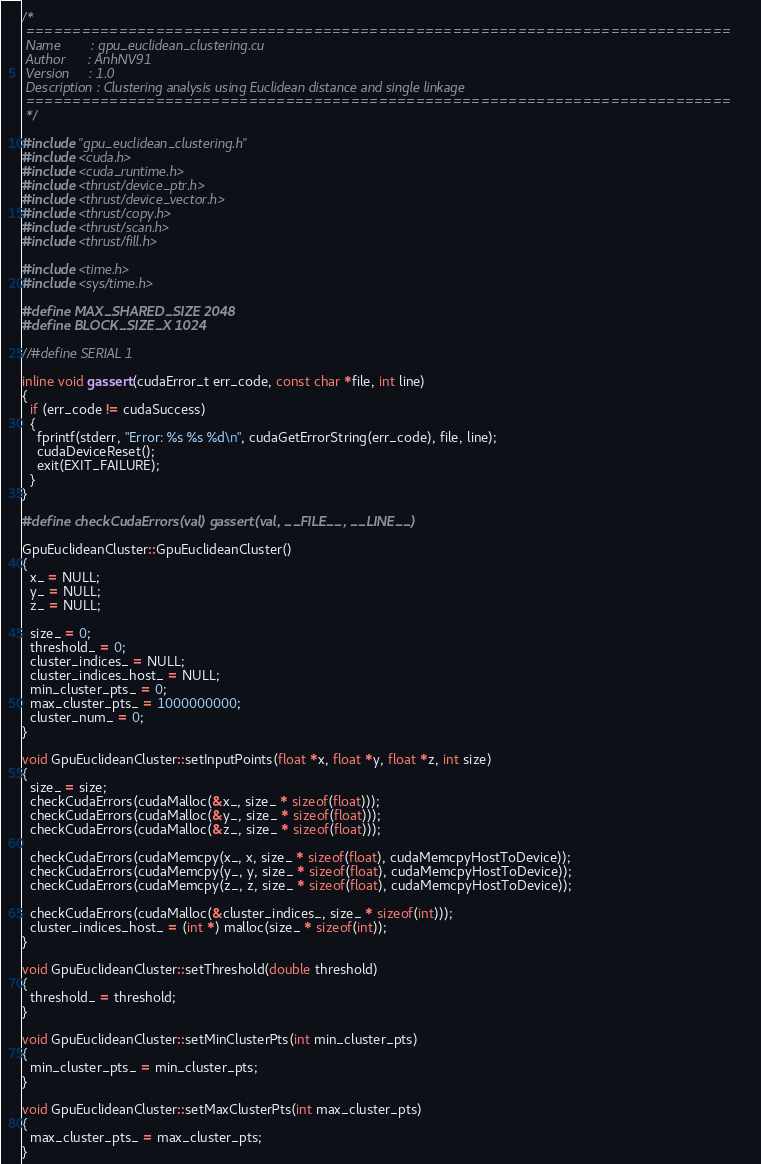Convert code to text. <code><loc_0><loc_0><loc_500><loc_500><_Cuda_>/*
 ============================================================================
 Name        : gpu_euclidean_clustering.cu
 Author      : AnhNV91
 Version     : 1.0
 Description : Clustering analysis using Euclidean distance and single linkage
 ============================================================================
 */

#include "gpu_euclidean_clustering.h"
#include <cuda.h>
#include <cuda_runtime.h>
#include <thrust/device_ptr.h>
#include <thrust/device_vector.h>
#include <thrust/copy.h>
#include <thrust/scan.h>
#include <thrust/fill.h>

#include <time.h>
#include <sys/time.h>

#define MAX_SHARED_SIZE 2048
#define BLOCK_SIZE_X 1024

//#define SERIAL 1

inline void gassert(cudaError_t err_code, const char *file, int line)
{
  if (err_code != cudaSuccess)
  {
    fprintf(stderr, "Error: %s %s %d\n", cudaGetErrorString(err_code), file, line);
    cudaDeviceReset();
    exit(EXIT_FAILURE);
  }
}

#define checkCudaErrors(val) gassert(val, __FILE__, __LINE__)

GpuEuclideanCluster::GpuEuclideanCluster()
{
  x_ = NULL;
  y_ = NULL;
  z_ = NULL;

  size_ = 0;
  threshold_ = 0;
  cluster_indices_ = NULL;
  cluster_indices_host_ = NULL;
  min_cluster_pts_ = 0;
  max_cluster_pts_ = 1000000000;
  cluster_num_ = 0;
}

void GpuEuclideanCluster::setInputPoints(float *x, float *y, float *z, int size)
{
  size_ = size;
  checkCudaErrors(cudaMalloc(&x_, size_ * sizeof(float)));
  checkCudaErrors(cudaMalloc(&y_, size_ * sizeof(float)));
  checkCudaErrors(cudaMalloc(&z_, size_ * sizeof(float)));

  checkCudaErrors(cudaMemcpy(x_, x, size_ * sizeof(float), cudaMemcpyHostToDevice));
  checkCudaErrors(cudaMemcpy(y_, y, size_ * sizeof(float), cudaMemcpyHostToDevice));
  checkCudaErrors(cudaMemcpy(z_, z, size_ * sizeof(float), cudaMemcpyHostToDevice));

  checkCudaErrors(cudaMalloc(&cluster_indices_, size_ * sizeof(int)));
  cluster_indices_host_ = (int *) malloc(size_ * sizeof(int));
}

void GpuEuclideanCluster::setThreshold(double threshold)
{
  threshold_ = threshold;
}

void GpuEuclideanCluster::setMinClusterPts(int min_cluster_pts)
{
  min_cluster_pts_ = min_cluster_pts;
}

void GpuEuclideanCluster::setMaxClusterPts(int max_cluster_pts)
{
  max_cluster_pts_ = max_cluster_pts;
}
</code> 